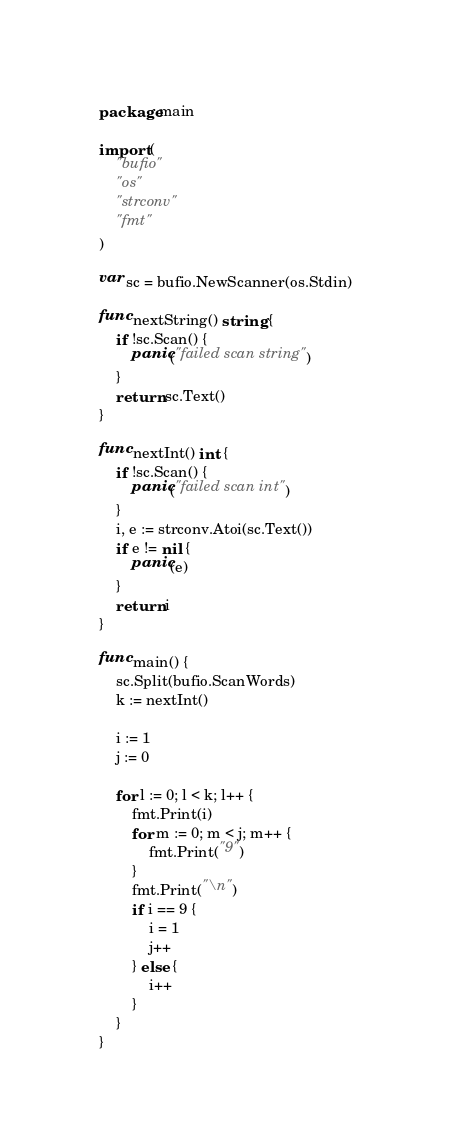<code> <loc_0><loc_0><loc_500><loc_500><_Go_>package main

import (
	"bufio"
	"os"
	"strconv"
	"fmt"
)

var sc = bufio.NewScanner(os.Stdin)

func nextString() string {
	if !sc.Scan() {
		panic("failed scan string")
	}
	return sc.Text()
}

func nextInt() int {
	if !sc.Scan() {
		panic("failed scan int")
	}
	i, e := strconv.Atoi(sc.Text())
	if e != nil {
		panic(e)
	}
	return i
}

func main() {
	sc.Split(bufio.ScanWords)
	k := nextInt()

	i := 1
	j := 0

	for l := 0; l < k; l++ {
		fmt.Print(i)
		for m := 0; m < j; m++ {
			fmt.Print("9")
		}
		fmt.Print("\n")
		if i == 9 {
			i = 1
			j++
		} else {
			i++
		}
	}
}
</code> 